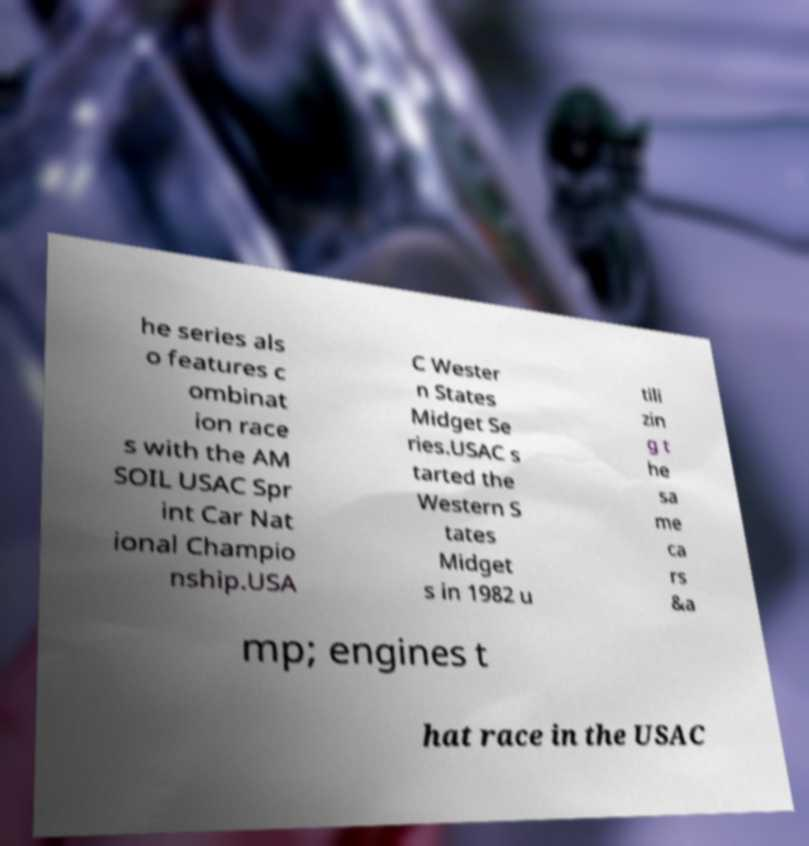Please identify and transcribe the text found in this image. he series als o features c ombinat ion race s with the AM SOIL USAC Spr int Car Nat ional Champio nship.USA C Wester n States Midget Se ries.USAC s tarted the Western S tates Midget s in 1982 u tili zin g t he sa me ca rs &a mp; engines t hat race in the USAC 